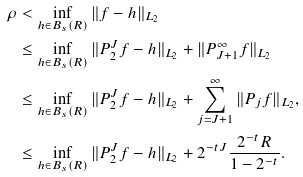<formula> <loc_0><loc_0><loc_500><loc_500>\rho & < \inf _ { h \in B _ { s } ( R ) } \| f - h \| _ { L _ { 2 } } \\ & \leq \inf _ { h \in B _ { s } ( R ) } \| P _ { 2 } ^ { J } f - h \| _ { L _ { 2 } } + \| P _ { J + 1 } ^ { \infty } f \| _ { L _ { 2 } } \\ & \leq \inf _ { h \in B _ { s } ( R ) } \| P _ { 2 } ^ { J } f - h \| _ { L _ { 2 } } + \sum _ { j = J + 1 } ^ { \infty } \| P _ { j } f \| _ { L _ { 2 } } , \\ & \leq \inf _ { h \in B _ { s } ( R ) } \| P _ { 2 } ^ { J } f - h \| _ { L _ { 2 } } + 2 ^ { - t J } \frac { 2 ^ { - t } R } { 1 - 2 ^ { - t } } .</formula> 